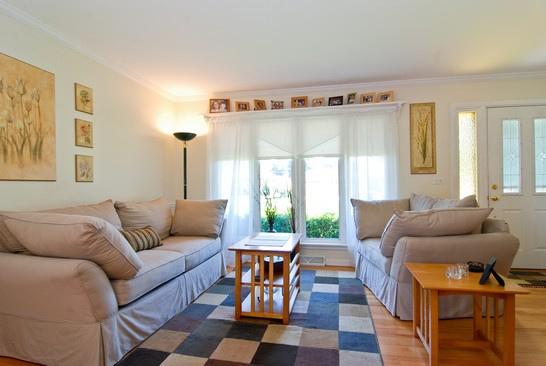How many picture frames are above the window?
Keep it brief. 10. Is there a rug?
Quick response, please. Yes. What kind of room is this?
Be succinct. Living room. How many windows are in this room?
Concise answer only. 7. Is this a hotel?
Concise answer only. No. 